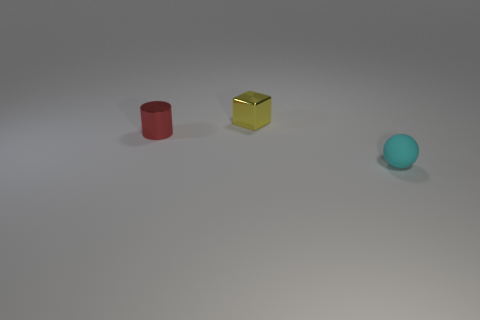Are there any tiny yellow metallic things that have the same shape as the red thing?
Make the answer very short. No. Are the thing in front of the tiny shiny cylinder and the thing that is behind the tiny cylinder made of the same material?
Keep it short and to the point. No. How many objects have the same material as the small cube?
Offer a very short reply. 1. What is the color of the block?
Provide a short and direct response. Yellow. There is a small object that is behind the shiny cylinder; is it the same shape as the small thing on the left side of the block?
Your answer should be very brief. No. There is a small metallic object that is in front of the tiny yellow cube; what is its color?
Offer a terse response. Red. Are there fewer tiny cylinders that are in front of the small yellow cube than tiny cylinders that are in front of the red metal cylinder?
Your answer should be compact. No. How many other things are there of the same material as the tiny yellow object?
Provide a short and direct response. 1. Is the material of the small yellow thing the same as the tiny cyan ball?
Give a very brief answer. No. What size is the thing to the right of the thing behind the red object?
Make the answer very short. Small. 